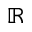Convert formula to latex. <formula><loc_0><loc_0><loc_500><loc_500>\mathbb { R }</formula> 